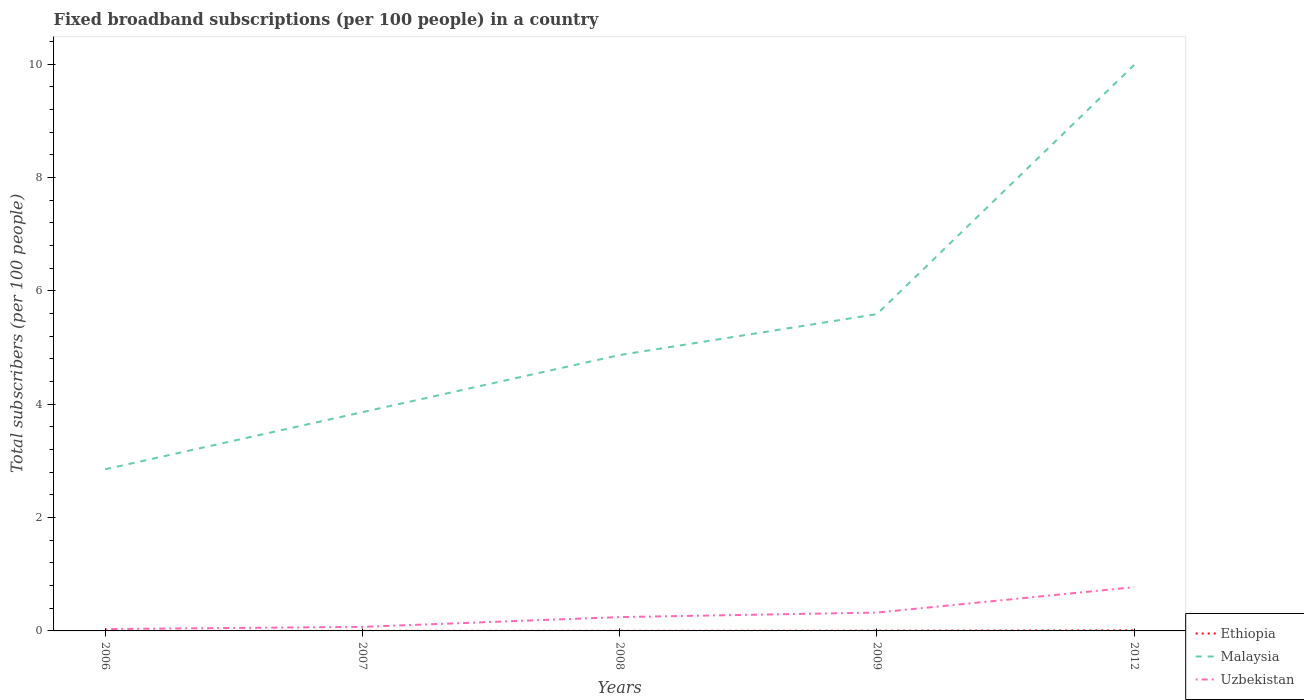How many different coloured lines are there?
Your answer should be compact. 3. Across all years, what is the maximum number of broadband subscriptions in Ethiopia?
Your response must be concise. 0. What is the total number of broadband subscriptions in Uzbekistan in the graph?
Offer a very short reply. -0.7. What is the difference between the highest and the second highest number of broadband subscriptions in Malaysia?
Make the answer very short. 7.14. What is the difference between the highest and the lowest number of broadband subscriptions in Uzbekistan?
Make the answer very short. 2. How many lines are there?
Your answer should be very brief. 3. What is the difference between two consecutive major ticks on the Y-axis?
Provide a short and direct response. 2. Are the values on the major ticks of Y-axis written in scientific E-notation?
Your answer should be very brief. No. Does the graph contain grids?
Keep it short and to the point. No. Where does the legend appear in the graph?
Keep it short and to the point. Bottom right. How are the legend labels stacked?
Give a very brief answer. Vertical. What is the title of the graph?
Offer a terse response. Fixed broadband subscriptions (per 100 people) in a country. What is the label or title of the X-axis?
Your answer should be very brief. Years. What is the label or title of the Y-axis?
Provide a succinct answer. Total subscribers (per 100 people). What is the Total subscribers (per 100 people) of Ethiopia in 2006?
Offer a terse response. 0. What is the Total subscribers (per 100 people) of Malaysia in 2006?
Provide a short and direct response. 2.85. What is the Total subscribers (per 100 people) in Uzbekistan in 2006?
Provide a short and direct response. 0.03. What is the Total subscribers (per 100 people) of Ethiopia in 2007?
Give a very brief answer. 0. What is the Total subscribers (per 100 people) in Malaysia in 2007?
Offer a very short reply. 3.86. What is the Total subscribers (per 100 people) of Uzbekistan in 2007?
Provide a succinct answer. 0.07. What is the Total subscribers (per 100 people) in Ethiopia in 2008?
Offer a terse response. 0. What is the Total subscribers (per 100 people) of Malaysia in 2008?
Your response must be concise. 4.87. What is the Total subscribers (per 100 people) in Uzbekistan in 2008?
Offer a terse response. 0.24. What is the Total subscribers (per 100 people) in Ethiopia in 2009?
Your answer should be compact. 0. What is the Total subscribers (per 100 people) in Malaysia in 2009?
Keep it short and to the point. 5.59. What is the Total subscribers (per 100 people) of Uzbekistan in 2009?
Provide a succinct answer. 0.32. What is the Total subscribers (per 100 people) in Ethiopia in 2012?
Ensure brevity in your answer.  0.01. What is the Total subscribers (per 100 people) in Malaysia in 2012?
Make the answer very short. 9.99. What is the Total subscribers (per 100 people) in Uzbekistan in 2012?
Keep it short and to the point. 0.77. Across all years, what is the maximum Total subscribers (per 100 people) in Ethiopia?
Make the answer very short. 0.01. Across all years, what is the maximum Total subscribers (per 100 people) of Malaysia?
Make the answer very short. 9.99. Across all years, what is the maximum Total subscribers (per 100 people) in Uzbekistan?
Provide a succinct answer. 0.77. Across all years, what is the minimum Total subscribers (per 100 people) in Ethiopia?
Your response must be concise. 0. Across all years, what is the minimum Total subscribers (per 100 people) in Malaysia?
Your answer should be compact. 2.85. Across all years, what is the minimum Total subscribers (per 100 people) in Uzbekistan?
Keep it short and to the point. 0.03. What is the total Total subscribers (per 100 people) in Ethiopia in the graph?
Provide a succinct answer. 0.02. What is the total Total subscribers (per 100 people) in Malaysia in the graph?
Offer a terse response. 27.16. What is the total Total subscribers (per 100 people) in Uzbekistan in the graph?
Provide a short and direct response. 1.45. What is the difference between the Total subscribers (per 100 people) in Ethiopia in 2006 and that in 2007?
Provide a short and direct response. -0. What is the difference between the Total subscribers (per 100 people) in Malaysia in 2006 and that in 2007?
Provide a succinct answer. -1.01. What is the difference between the Total subscribers (per 100 people) of Uzbekistan in 2006 and that in 2007?
Your answer should be compact. -0.04. What is the difference between the Total subscribers (per 100 people) of Ethiopia in 2006 and that in 2008?
Offer a very short reply. -0. What is the difference between the Total subscribers (per 100 people) in Malaysia in 2006 and that in 2008?
Give a very brief answer. -2.02. What is the difference between the Total subscribers (per 100 people) of Uzbekistan in 2006 and that in 2008?
Provide a succinct answer. -0.21. What is the difference between the Total subscribers (per 100 people) of Ethiopia in 2006 and that in 2009?
Give a very brief answer. -0. What is the difference between the Total subscribers (per 100 people) of Malaysia in 2006 and that in 2009?
Your answer should be very brief. -2.74. What is the difference between the Total subscribers (per 100 people) in Uzbekistan in 2006 and that in 2009?
Your response must be concise. -0.29. What is the difference between the Total subscribers (per 100 people) in Ethiopia in 2006 and that in 2012?
Provide a succinct answer. -0.01. What is the difference between the Total subscribers (per 100 people) of Malaysia in 2006 and that in 2012?
Make the answer very short. -7.14. What is the difference between the Total subscribers (per 100 people) in Uzbekistan in 2006 and that in 2012?
Offer a very short reply. -0.74. What is the difference between the Total subscribers (per 100 people) of Ethiopia in 2007 and that in 2008?
Your response must be concise. -0. What is the difference between the Total subscribers (per 100 people) in Malaysia in 2007 and that in 2008?
Your answer should be compact. -1.01. What is the difference between the Total subscribers (per 100 people) of Uzbekistan in 2007 and that in 2008?
Your answer should be very brief. -0.17. What is the difference between the Total subscribers (per 100 people) of Ethiopia in 2007 and that in 2009?
Make the answer very short. -0. What is the difference between the Total subscribers (per 100 people) in Malaysia in 2007 and that in 2009?
Make the answer very short. -1.73. What is the difference between the Total subscribers (per 100 people) of Uzbekistan in 2007 and that in 2009?
Your answer should be very brief. -0.25. What is the difference between the Total subscribers (per 100 people) of Ethiopia in 2007 and that in 2012?
Ensure brevity in your answer.  -0.01. What is the difference between the Total subscribers (per 100 people) of Malaysia in 2007 and that in 2012?
Your answer should be very brief. -6.13. What is the difference between the Total subscribers (per 100 people) of Uzbekistan in 2007 and that in 2012?
Offer a terse response. -0.7. What is the difference between the Total subscribers (per 100 people) in Ethiopia in 2008 and that in 2009?
Keep it short and to the point. -0. What is the difference between the Total subscribers (per 100 people) of Malaysia in 2008 and that in 2009?
Provide a short and direct response. -0.72. What is the difference between the Total subscribers (per 100 people) of Uzbekistan in 2008 and that in 2009?
Offer a very short reply. -0.08. What is the difference between the Total subscribers (per 100 people) of Ethiopia in 2008 and that in 2012?
Your answer should be very brief. -0.01. What is the difference between the Total subscribers (per 100 people) of Malaysia in 2008 and that in 2012?
Keep it short and to the point. -5.12. What is the difference between the Total subscribers (per 100 people) of Uzbekistan in 2008 and that in 2012?
Your answer should be compact. -0.53. What is the difference between the Total subscribers (per 100 people) in Ethiopia in 2009 and that in 2012?
Your response must be concise. -0.01. What is the difference between the Total subscribers (per 100 people) in Malaysia in 2009 and that in 2012?
Keep it short and to the point. -4.4. What is the difference between the Total subscribers (per 100 people) of Uzbekistan in 2009 and that in 2012?
Make the answer very short. -0.45. What is the difference between the Total subscribers (per 100 people) in Ethiopia in 2006 and the Total subscribers (per 100 people) in Malaysia in 2007?
Your answer should be compact. -3.86. What is the difference between the Total subscribers (per 100 people) in Ethiopia in 2006 and the Total subscribers (per 100 people) in Uzbekistan in 2007?
Your response must be concise. -0.07. What is the difference between the Total subscribers (per 100 people) of Malaysia in 2006 and the Total subscribers (per 100 people) of Uzbekistan in 2007?
Your answer should be compact. 2.78. What is the difference between the Total subscribers (per 100 people) in Ethiopia in 2006 and the Total subscribers (per 100 people) in Malaysia in 2008?
Provide a succinct answer. -4.87. What is the difference between the Total subscribers (per 100 people) in Ethiopia in 2006 and the Total subscribers (per 100 people) in Uzbekistan in 2008?
Your response must be concise. -0.24. What is the difference between the Total subscribers (per 100 people) in Malaysia in 2006 and the Total subscribers (per 100 people) in Uzbekistan in 2008?
Offer a terse response. 2.61. What is the difference between the Total subscribers (per 100 people) of Ethiopia in 2006 and the Total subscribers (per 100 people) of Malaysia in 2009?
Give a very brief answer. -5.59. What is the difference between the Total subscribers (per 100 people) of Ethiopia in 2006 and the Total subscribers (per 100 people) of Uzbekistan in 2009?
Make the answer very short. -0.32. What is the difference between the Total subscribers (per 100 people) of Malaysia in 2006 and the Total subscribers (per 100 people) of Uzbekistan in 2009?
Provide a short and direct response. 2.53. What is the difference between the Total subscribers (per 100 people) of Ethiopia in 2006 and the Total subscribers (per 100 people) of Malaysia in 2012?
Provide a short and direct response. -9.99. What is the difference between the Total subscribers (per 100 people) in Ethiopia in 2006 and the Total subscribers (per 100 people) in Uzbekistan in 2012?
Provide a short and direct response. -0.77. What is the difference between the Total subscribers (per 100 people) in Malaysia in 2006 and the Total subscribers (per 100 people) in Uzbekistan in 2012?
Offer a very short reply. 2.08. What is the difference between the Total subscribers (per 100 people) in Ethiopia in 2007 and the Total subscribers (per 100 people) in Malaysia in 2008?
Make the answer very short. -4.87. What is the difference between the Total subscribers (per 100 people) of Ethiopia in 2007 and the Total subscribers (per 100 people) of Uzbekistan in 2008?
Your answer should be very brief. -0.24. What is the difference between the Total subscribers (per 100 people) in Malaysia in 2007 and the Total subscribers (per 100 people) in Uzbekistan in 2008?
Offer a terse response. 3.62. What is the difference between the Total subscribers (per 100 people) in Ethiopia in 2007 and the Total subscribers (per 100 people) in Malaysia in 2009?
Keep it short and to the point. -5.59. What is the difference between the Total subscribers (per 100 people) of Ethiopia in 2007 and the Total subscribers (per 100 people) of Uzbekistan in 2009?
Give a very brief answer. -0.32. What is the difference between the Total subscribers (per 100 people) in Malaysia in 2007 and the Total subscribers (per 100 people) in Uzbekistan in 2009?
Offer a terse response. 3.54. What is the difference between the Total subscribers (per 100 people) in Ethiopia in 2007 and the Total subscribers (per 100 people) in Malaysia in 2012?
Offer a terse response. -9.99. What is the difference between the Total subscribers (per 100 people) in Ethiopia in 2007 and the Total subscribers (per 100 people) in Uzbekistan in 2012?
Make the answer very short. -0.77. What is the difference between the Total subscribers (per 100 people) of Malaysia in 2007 and the Total subscribers (per 100 people) of Uzbekistan in 2012?
Offer a terse response. 3.09. What is the difference between the Total subscribers (per 100 people) in Ethiopia in 2008 and the Total subscribers (per 100 people) in Malaysia in 2009?
Give a very brief answer. -5.59. What is the difference between the Total subscribers (per 100 people) in Ethiopia in 2008 and the Total subscribers (per 100 people) in Uzbekistan in 2009?
Your answer should be compact. -0.32. What is the difference between the Total subscribers (per 100 people) in Malaysia in 2008 and the Total subscribers (per 100 people) in Uzbekistan in 2009?
Offer a terse response. 4.54. What is the difference between the Total subscribers (per 100 people) in Ethiopia in 2008 and the Total subscribers (per 100 people) in Malaysia in 2012?
Your answer should be very brief. -9.99. What is the difference between the Total subscribers (per 100 people) in Ethiopia in 2008 and the Total subscribers (per 100 people) in Uzbekistan in 2012?
Make the answer very short. -0.77. What is the difference between the Total subscribers (per 100 people) of Malaysia in 2008 and the Total subscribers (per 100 people) of Uzbekistan in 2012?
Offer a terse response. 4.1. What is the difference between the Total subscribers (per 100 people) of Ethiopia in 2009 and the Total subscribers (per 100 people) of Malaysia in 2012?
Keep it short and to the point. -9.99. What is the difference between the Total subscribers (per 100 people) in Ethiopia in 2009 and the Total subscribers (per 100 people) in Uzbekistan in 2012?
Offer a very short reply. -0.77. What is the difference between the Total subscribers (per 100 people) of Malaysia in 2009 and the Total subscribers (per 100 people) of Uzbekistan in 2012?
Offer a terse response. 4.82. What is the average Total subscribers (per 100 people) in Ethiopia per year?
Make the answer very short. 0. What is the average Total subscribers (per 100 people) in Malaysia per year?
Offer a terse response. 5.43. What is the average Total subscribers (per 100 people) of Uzbekistan per year?
Make the answer very short. 0.29. In the year 2006, what is the difference between the Total subscribers (per 100 people) in Ethiopia and Total subscribers (per 100 people) in Malaysia?
Your answer should be compact. -2.85. In the year 2006, what is the difference between the Total subscribers (per 100 people) of Ethiopia and Total subscribers (per 100 people) of Uzbekistan?
Provide a succinct answer. -0.03. In the year 2006, what is the difference between the Total subscribers (per 100 people) in Malaysia and Total subscribers (per 100 people) in Uzbekistan?
Offer a terse response. 2.82. In the year 2007, what is the difference between the Total subscribers (per 100 people) in Ethiopia and Total subscribers (per 100 people) in Malaysia?
Provide a short and direct response. -3.86. In the year 2007, what is the difference between the Total subscribers (per 100 people) in Ethiopia and Total subscribers (per 100 people) in Uzbekistan?
Ensure brevity in your answer.  -0.07. In the year 2007, what is the difference between the Total subscribers (per 100 people) in Malaysia and Total subscribers (per 100 people) in Uzbekistan?
Your answer should be very brief. 3.79. In the year 2008, what is the difference between the Total subscribers (per 100 people) of Ethiopia and Total subscribers (per 100 people) of Malaysia?
Make the answer very short. -4.87. In the year 2008, what is the difference between the Total subscribers (per 100 people) of Ethiopia and Total subscribers (per 100 people) of Uzbekistan?
Provide a short and direct response. -0.24. In the year 2008, what is the difference between the Total subscribers (per 100 people) in Malaysia and Total subscribers (per 100 people) in Uzbekistan?
Your response must be concise. 4.62. In the year 2009, what is the difference between the Total subscribers (per 100 people) in Ethiopia and Total subscribers (per 100 people) in Malaysia?
Your answer should be very brief. -5.59. In the year 2009, what is the difference between the Total subscribers (per 100 people) of Ethiopia and Total subscribers (per 100 people) of Uzbekistan?
Your response must be concise. -0.32. In the year 2009, what is the difference between the Total subscribers (per 100 people) of Malaysia and Total subscribers (per 100 people) of Uzbekistan?
Keep it short and to the point. 5.27. In the year 2012, what is the difference between the Total subscribers (per 100 people) of Ethiopia and Total subscribers (per 100 people) of Malaysia?
Give a very brief answer. -9.98. In the year 2012, what is the difference between the Total subscribers (per 100 people) of Ethiopia and Total subscribers (per 100 people) of Uzbekistan?
Offer a terse response. -0.76. In the year 2012, what is the difference between the Total subscribers (per 100 people) in Malaysia and Total subscribers (per 100 people) in Uzbekistan?
Your answer should be compact. 9.22. What is the ratio of the Total subscribers (per 100 people) in Ethiopia in 2006 to that in 2007?
Give a very brief answer. 0.26. What is the ratio of the Total subscribers (per 100 people) in Malaysia in 2006 to that in 2007?
Make the answer very short. 0.74. What is the ratio of the Total subscribers (per 100 people) in Uzbekistan in 2006 to that in 2007?
Your answer should be very brief. 0.46. What is the ratio of the Total subscribers (per 100 people) in Ethiopia in 2006 to that in 2008?
Keep it short and to the point. 0.18. What is the ratio of the Total subscribers (per 100 people) in Malaysia in 2006 to that in 2008?
Offer a terse response. 0.59. What is the ratio of the Total subscribers (per 100 people) of Uzbekistan in 2006 to that in 2008?
Keep it short and to the point. 0.13. What is the ratio of the Total subscribers (per 100 people) of Ethiopia in 2006 to that in 2009?
Offer a terse response. 0.08. What is the ratio of the Total subscribers (per 100 people) in Malaysia in 2006 to that in 2009?
Your response must be concise. 0.51. What is the ratio of the Total subscribers (per 100 people) of Uzbekistan in 2006 to that in 2009?
Your answer should be compact. 0.1. What is the ratio of the Total subscribers (per 100 people) in Ethiopia in 2006 to that in 2012?
Your answer should be very brief. 0.04. What is the ratio of the Total subscribers (per 100 people) in Malaysia in 2006 to that in 2012?
Keep it short and to the point. 0.29. What is the ratio of the Total subscribers (per 100 people) in Uzbekistan in 2006 to that in 2012?
Offer a very short reply. 0.04. What is the ratio of the Total subscribers (per 100 people) of Ethiopia in 2007 to that in 2008?
Offer a very short reply. 0.71. What is the ratio of the Total subscribers (per 100 people) of Malaysia in 2007 to that in 2008?
Keep it short and to the point. 0.79. What is the ratio of the Total subscribers (per 100 people) in Uzbekistan in 2007 to that in 2008?
Provide a short and direct response. 0.29. What is the ratio of the Total subscribers (per 100 people) in Ethiopia in 2007 to that in 2009?
Give a very brief answer. 0.31. What is the ratio of the Total subscribers (per 100 people) in Malaysia in 2007 to that in 2009?
Offer a very short reply. 0.69. What is the ratio of the Total subscribers (per 100 people) of Uzbekistan in 2007 to that in 2009?
Offer a terse response. 0.22. What is the ratio of the Total subscribers (per 100 people) in Ethiopia in 2007 to that in 2012?
Provide a succinct answer. 0.14. What is the ratio of the Total subscribers (per 100 people) of Malaysia in 2007 to that in 2012?
Ensure brevity in your answer.  0.39. What is the ratio of the Total subscribers (per 100 people) in Uzbekistan in 2007 to that in 2012?
Keep it short and to the point. 0.09. What is the ratio of the Total subscribers (per 100 people) of Ethiopia in 2008 to that in 2009?
Provide a short and direct response. 0.44. What is the ratio of the Total subscribers (per 100 people) in Malaysia in 2008 to that in 2009?
Keep it short and to the point. 0.87. What is the ratio of the Total subscribers (per 100 people) in Uzbekistan in 2008 to that in 2009?
Your answer should be very brief. 0.75. What is the ratio of the Total subscribers (per 100 people) of Ethiopia in 2008 to that in 2012?
Your answer should be compact. 0.19. What is the ratio of the Total subscribers (per 100 people) of Malaysia in 2008 to that in 2012?
Provide a short and direct response. 0.49. What is the ratio of the Total subscribers (per 100 people) of Uzbekistan in 2008 to that in 2012?
Make the answer very short. 0.32. What is the ratio of the Total subscribers (per 100 people) of Ethiopia in 2009 to that in 2012?
Provide a short and direct response. 0.44. What is the ratio of the Total subscribers (per 100 people) of Malaysia in 2009 to that in 2012?
Ensure brevity in your answer.  0.56. What is the ratio of the Total subscribers (per 100 people) of Uzbekistan in 2009 to that in 2012?
Offer a very short reply. 0.42. What is the difference between the highest and the second highest Total subscribers (per 100 people) of Ethiopia?
Your answer should be compact. 0.01. What is the difference between the highest and the second highest Total subscribers (per 100 people) of Malaysia?
Ensure brevity in your answer.  4.4. What is the difference between the highest and the second highest Total subscribers (per 100 people) of Uzbekistan?
Make the answer very short. 0.45. What is the difference between the highest and the lowest Total subscribers (per 100 people) in Ethiopia?
Your response must be concise. 0.01. What is the difference between the highest and the lowest Total subscribers (per 100 people) of Malaysia?
Provide a short and direct response. 7.14. What is the difference between the highest and the lowest Total subscribers (per 100 people) of Uzbekistan?
Keep it short and to the point. 0.74. 